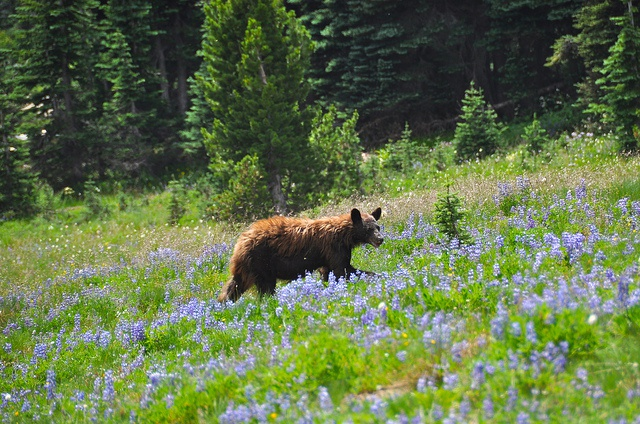Describe the objects in this image and their specific colors. I can see a bear in black, maroon, tan, and gray tones in this image. 